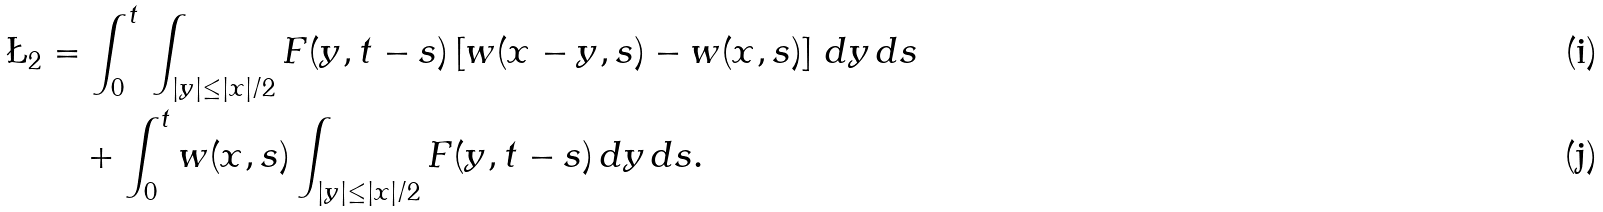<formula> <loc_0><loc_0><loc_500><loc_500>\L _ { 2 } & = \int _ { 0 } ^ { t } \, \int _ { | y | \leq | x | / 2 } F ( y , t - s ) \left [ w ( x - y , s ) - w ( x , s ) \right ] \, d y \, d s \\ & \quad + \int _ { 0 } ^ { t } w ( x , s ) \int _ { | y | \leq | x | / 2 } F ( y , t - s ) \, d y \, d s .</formula> 